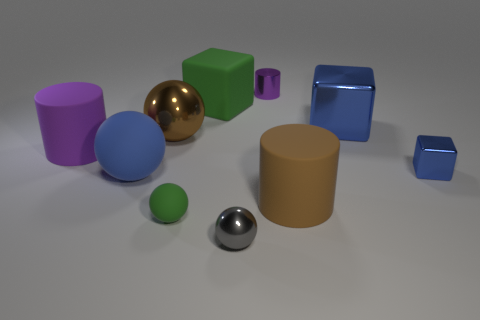There is a shiny thing in front of the big sphere that is in front of the large brown ball right of the large purple cylinder; what color is it?
Your answer should be very brief. Gray. There is a blue cube that is the same size as the blue rubber object; what material is it?
Make the answer very short. Metal. What number of things are purple objects on the right side of the tiny green sphere or yellow shiny cubes?
Ensure brevity in your answer.  1. Are there any small cyan metal spheres?
Make the answer very short. No. There is a tiny gray sphere left of the purple metal thing; what material is it?
Make the answer very short. Metal. What is the material of the sphere that is the same color as the rubber block?
Offer a very short reply. Rubber. What number of large objects are red metal blocks or blue cubes?
Your response must be concise. 1. The big shiny sphere has what color?
Your answer should be compact. Brown. There is a purple cylinder on the left side of the tiny green matte thing; are there any cubes in front of it?
Offer a terse response. Yes. Are there fewer big brown rubber cylinders on the left side of the gray ball than tiny purple balls?
Ensure brevity in your answer.  No. 